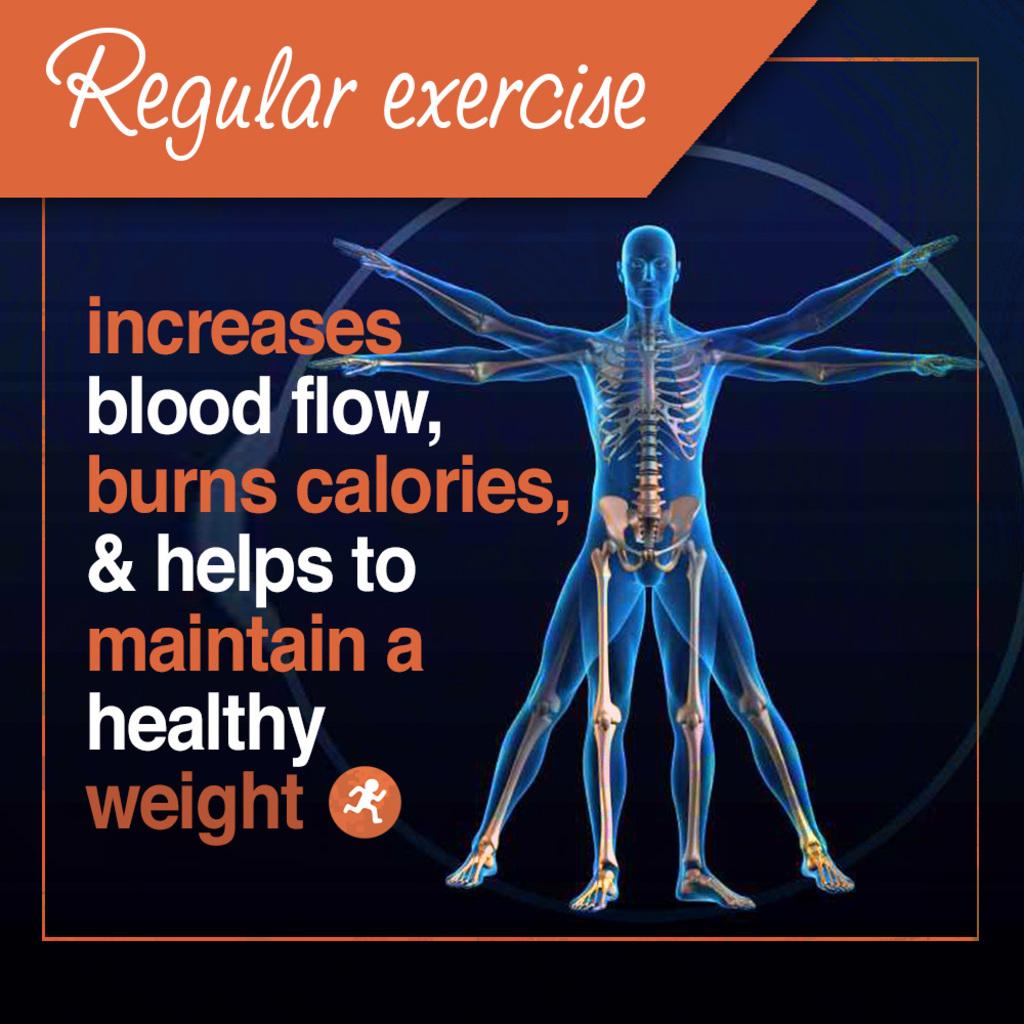Does regular exercise increase or decrease blood flow?
Your answer should be compact. Increase. Does exercise help you maintain a healthy weight?
Give a very brief answer. Yes. 